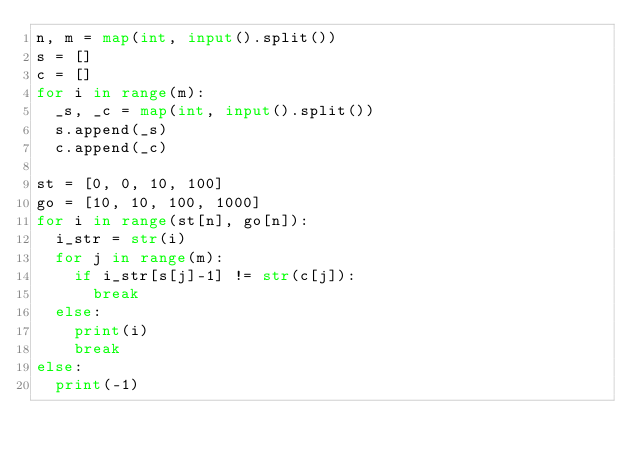<code> <loc_0><loc_0><loc_500><loc_500><_Python_>n, m = map(int, input().split())
s = []
c = []
for i in range(m):
  _s, _c = map(int, input().split())
  s.append(_s)
  c.append(_c)

st = [0, 0, 10, 100]
go = [10, 10, 100, 1000]
for i in range(st[n], go[n]):
  i_str = str(i)
  for j in range(m):
    if i_str[s[j]-1] != str(c[j]):
      break
  else:
    print(i)
    break
else:
  print(-1)</code> 